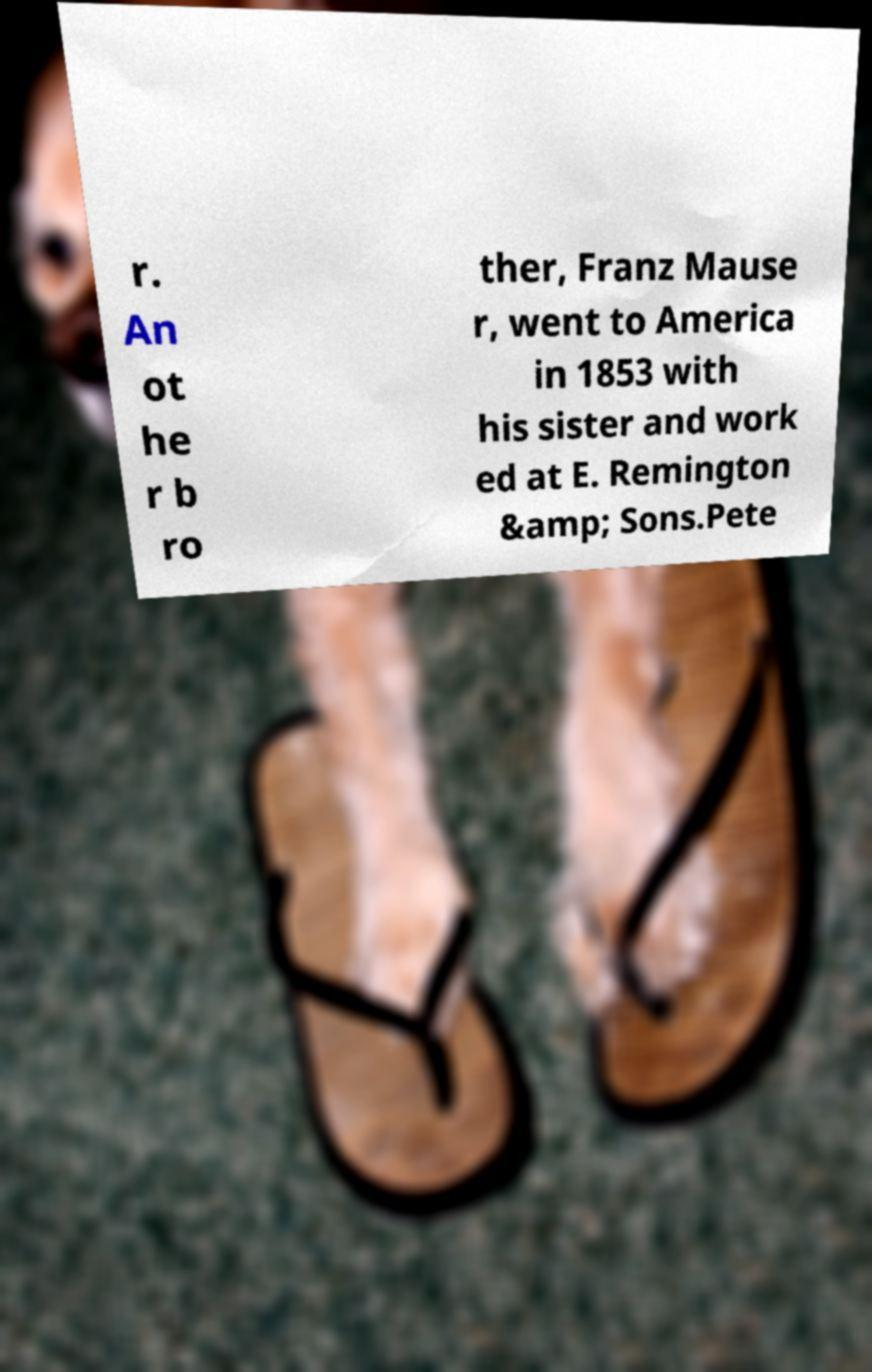For documentation purposes, I need the text within this image transcribed. Could you provide that? r. An ot he r b ro ther, Franz Mause r, went to America in 1853 with his sister and work ed at E. Remington &amp; Sons.Pete 